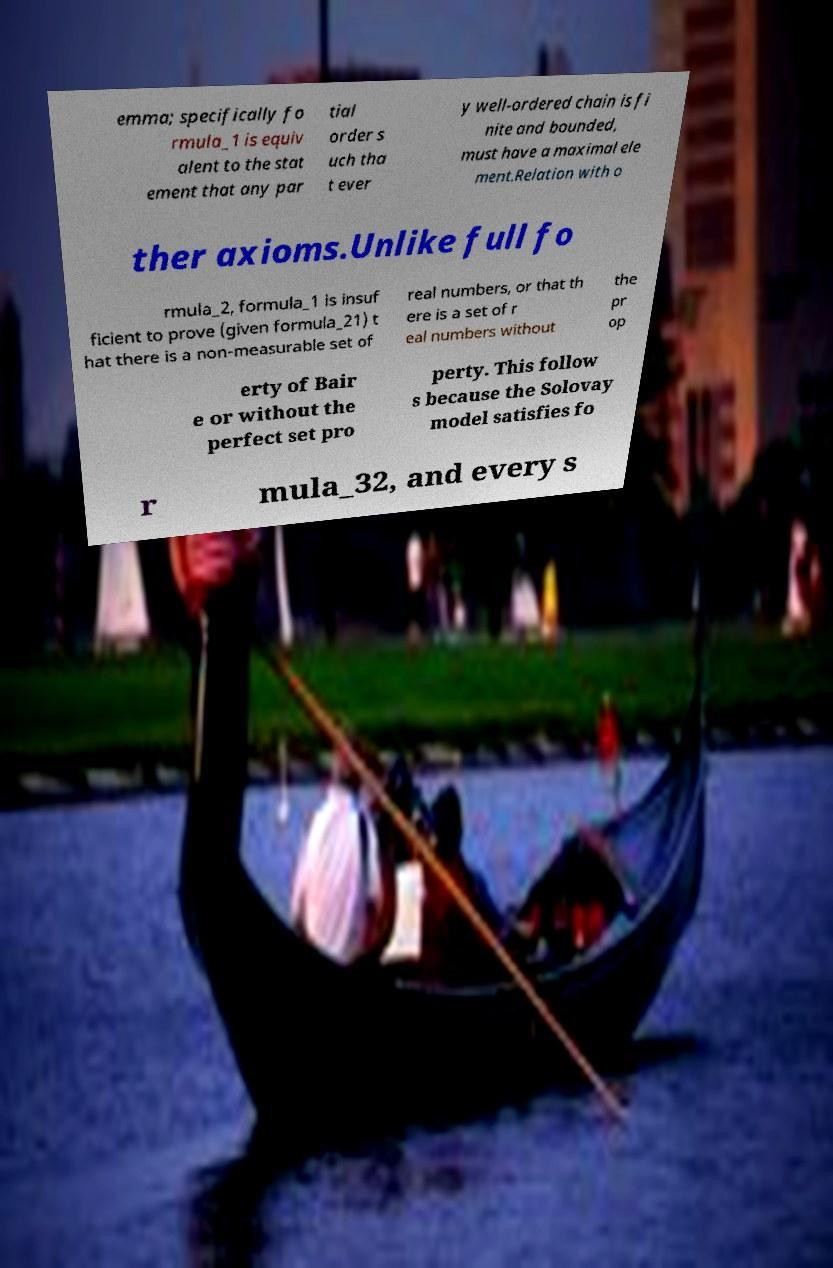There's text embedded in this image that I need extracted. Can you transcribe it verbatim? emma; specifically fo rmula_1 is equiv alent to the stat ement that any par tial order s uch tha t ever y well-ordered chain is fi nite and bounded, must have a maximal ele ment.Relation with o ther axioms.Unlike full fo rmula_2, formula_1 is insuf ficient to prove (given formula_21) t hat there is a non-measurable set of real numbers, or that th ere is a set of r eal numbers without the pr op erty of Bair e or without the perfect set pro perty. This follow s because the Solovay model satisfies fo r mula_32, and every s 